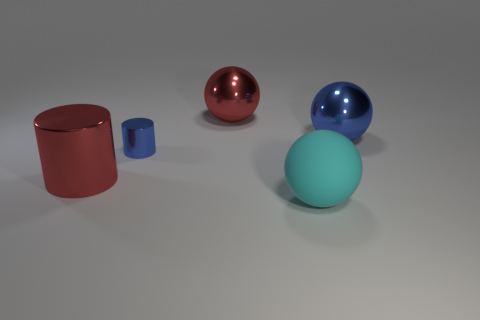Subtract all cyan spheres. How many spheres are left? 2 Subtract all spheres. How many objects are left? 2 Subtract all cyan balls. How many balls are left? 2 Subtract 1 balls. How many balls are left? 2 Subtract all brown metal spheres. Subtract all red balls. How many objects are left? 4 Add 3 large spheres. How many large spheres are left? 6 Add 3 big spheres. How many big spheres exist? 6 Add 5 red spheres. How many objects exist? 10 Subtract 0 red blocks. How many objects are left? 5 Subtract all gray cylinders. Subtract all cyan spheres. How many cylinders are left? 2 